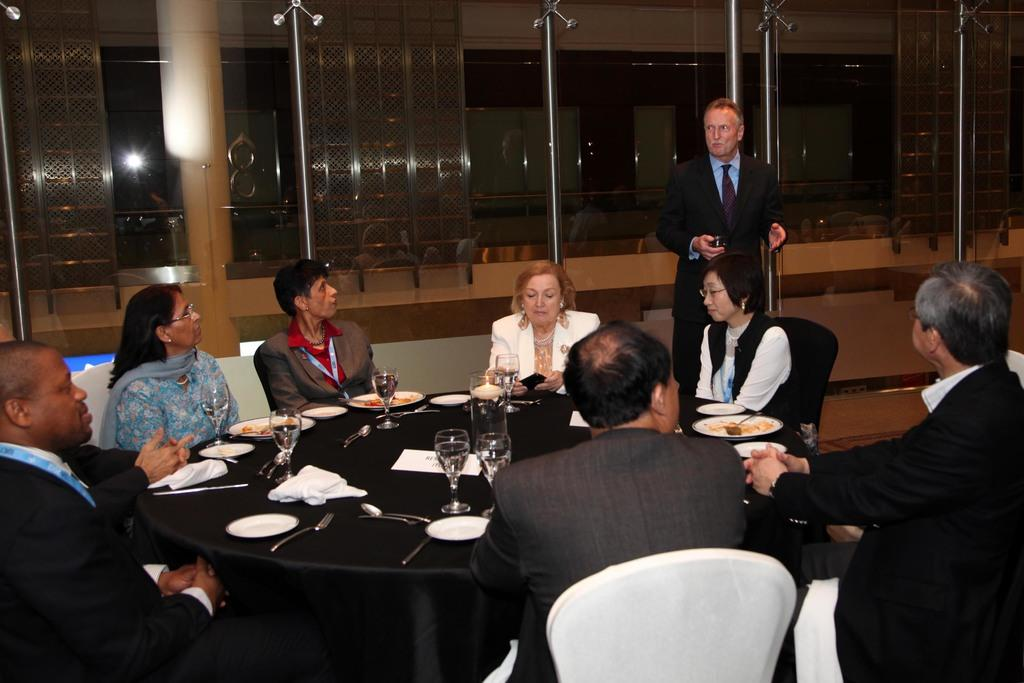What type of structure can be seen in the image? There is a wall in the image. What feature allows light and air to enter the room? There is a window in the image. What are the people in the image doing? There are people sitting on chairs in the image. What piece of furniture is present in the image? There is a table in the image. What items can be seen on the table? There are plates, spoons, and glasses on the table. What is the value of the tongue in the image? There is no tongue present in the image, so it is not possible to determine its value. 